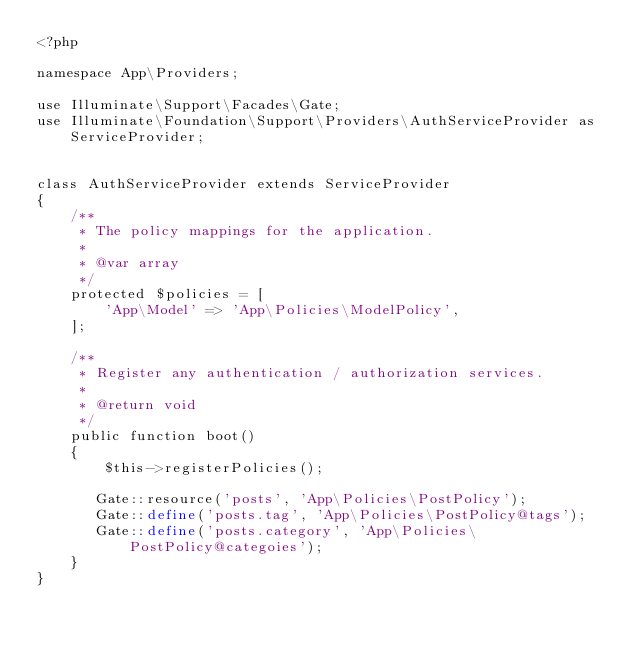<code> <loc_0><loc_0><loc_500><loc_500><_PHP_><?php

namespace App\Providers;

use Illuminate\Support\Facades\Gate;
use Illuminate\Foundation\Support\Providers\AuthServiceProvider as ServiceProvider;


class AuthServiceProvider extends ServiceProvider
{
    /**
     * The policy mappings for the application.
     *
     * @var array
     */
    protected $policies = [
        'App\Model' => 'App\Policies\ModelPolicy',
    ];

    /**
     * Register any authentication / authorization services.
     *
     * @return void
     */
    public function boot()
    {
        $this->registerPolicies();

       Gate::resource('posts', 'App\Policies\PostPolicy');
       Gate::define('posts.tag', 'App\Policies\PostPolicy@tags');
       Gate::define('posts.category', 'App\Policies\PostPolicy@categoies');
    }
}
</code> 